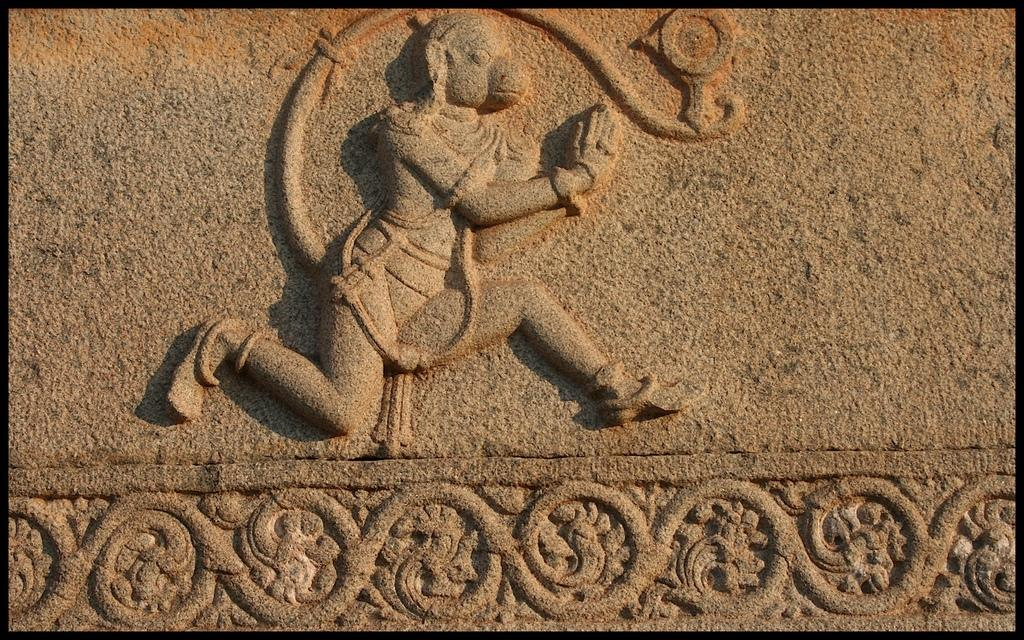What type of design is featured in the image? There is a stone carving design in the image. What subject matter is depicted in the design? The design depicts a god. How many cars are parked in front of the stone carving in the image? There are no cars present in the image; it features a stone carving design depicting a god. What type of mark can be seen on the grass near the stone carving? There is no grass or mark present in the image; it only features a stone carving design depicting a god. 